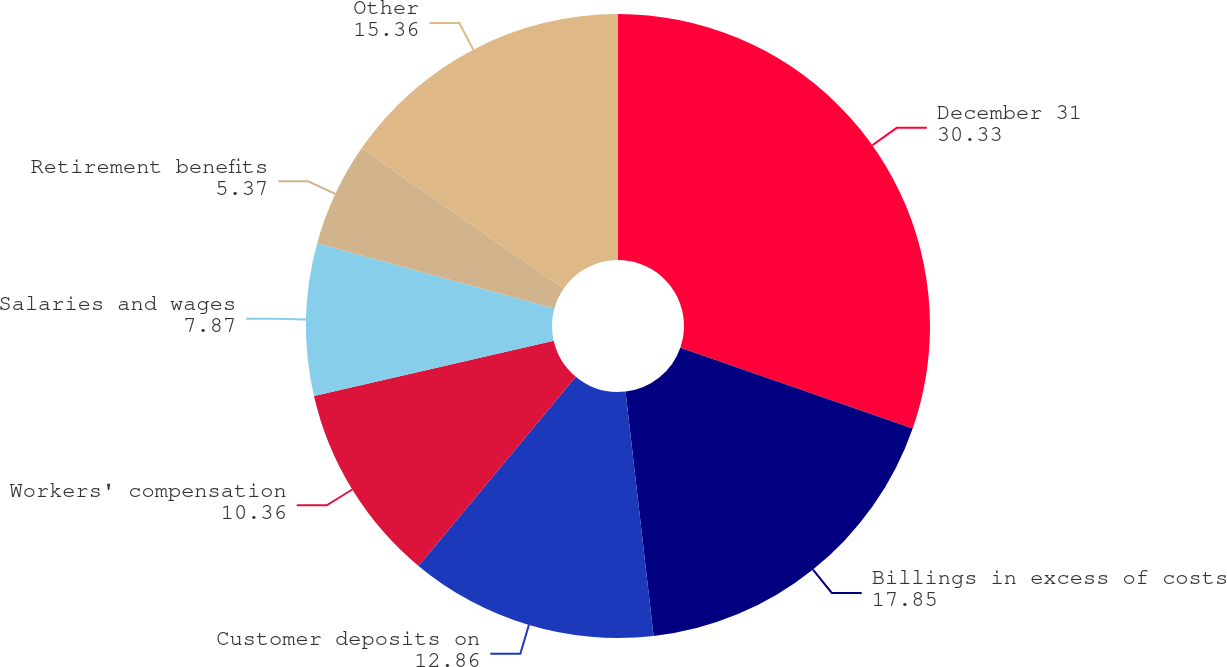Convert chart to OTSL. <chart><loc_0><loc_0><loc_500><loc_500><pie_chart><fcel>December 31<fcel>Billings in excess of costs<fcel>Customer deposits on<fcel>Workers' compensation<fcel>Salaries and wages<fcel>Retirement benefits<fcel>Other<nl><fcel>30.33%<fcel>17.85%<fcel>12.86%<fcel>10.36%<fcel>7.87%<fcel>5.37%<fcel>15.36%<nl></chart> 